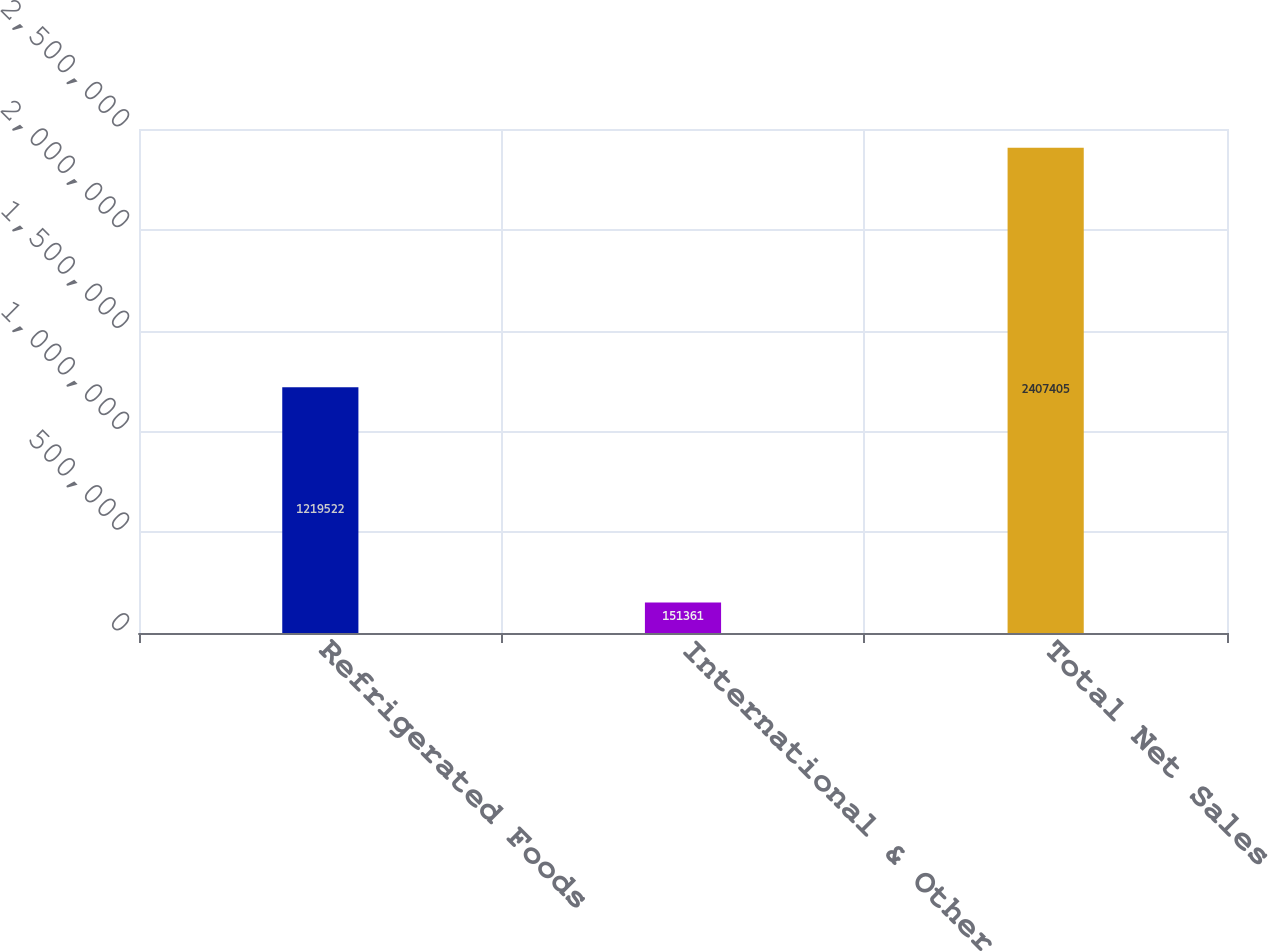Convert chart to OTSL. <chart><loc_0><loc_0><loc_500><loc_500><bar_chart><fcel>Refrigerated Foods<fcel>International & Other<fcel>Total Net Sales<nl><fcel>1.21952e+06<fcel>151361<fcel>2.4074e+06<nl></chart> 